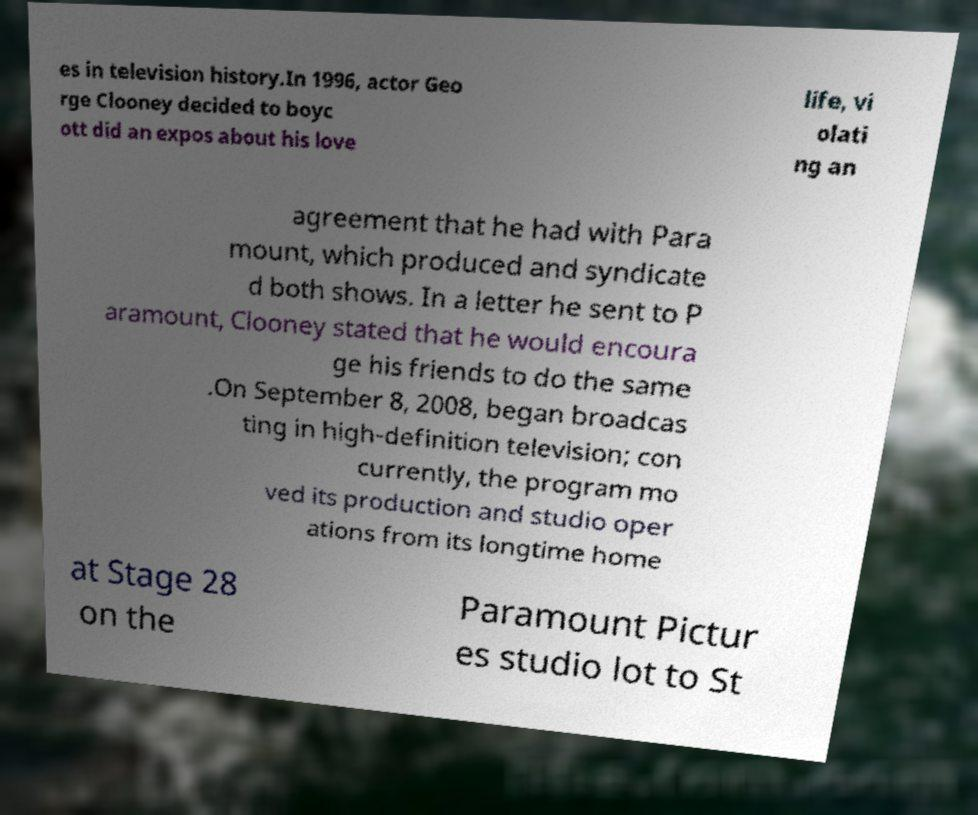I need the written content from this picture converted into text. Can you do that? es in television history.In 1996, actor Geo rge Clooney decided to boyc ott did an expos about his love life, vi olati ng an agreement that he had with Para mount, which produced and syndicate d both shows. In a letter he sent to P aramount, Clooney stated that he would encoura ge his friends to do the same .On September 8, 2008, began broadcas ting in high-definition television; con currently, the program mo ved its production and studio oper ations from its longtime home at Stage 28 on the Paramount Pictur es studio lot to St 